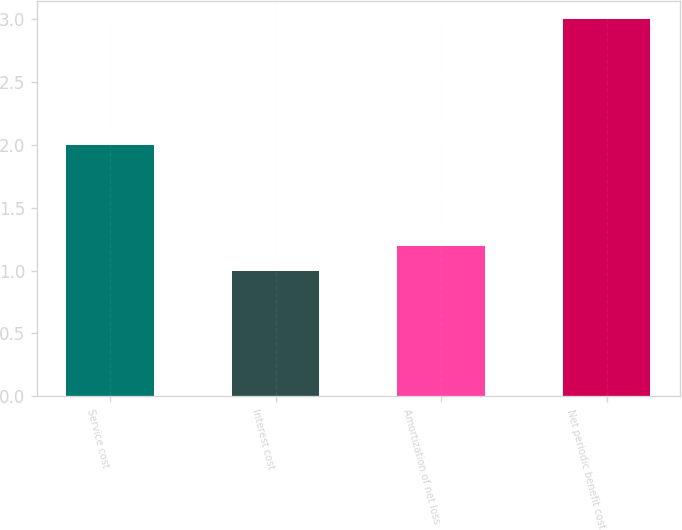Convert chart. <chart><loc_0><loc_0><loc_500><loc_500><bar_chart><fcel>Service cost<fcel>Interest cost<fcel>Amortization of net loss<fcel>Net periodic benefit cost<nl><fcel>2<fcel>1<fcel>1.2<fcel>3<nl></chart> 